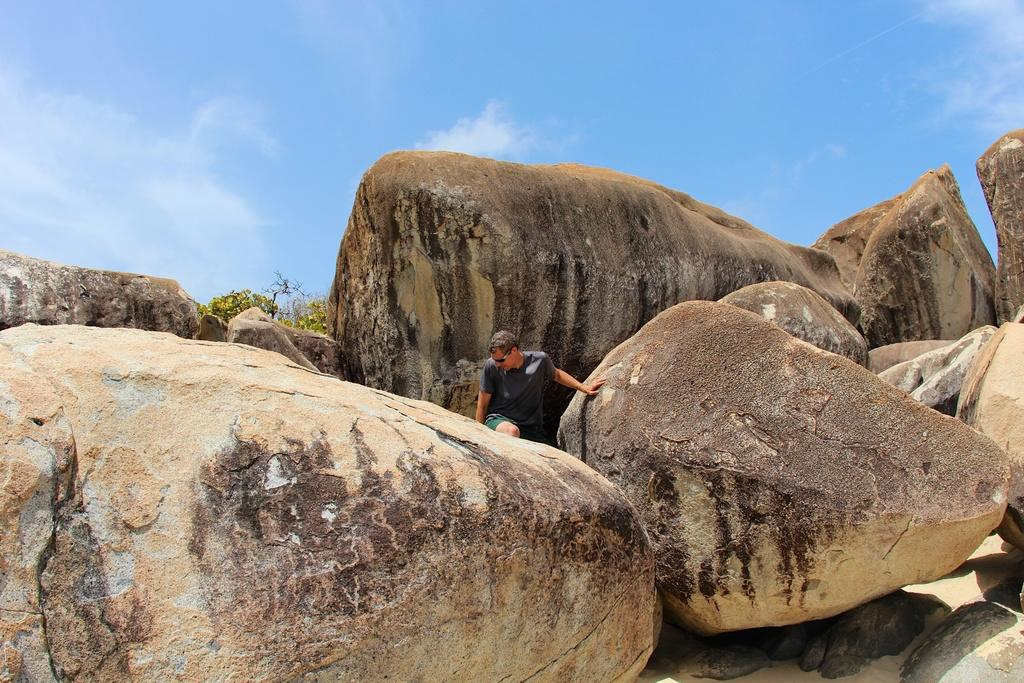Who is the main subject in the image? There is a man in the center of the image. What is surrounding the man? There are rocks around the man. What type of natural environment can be seen in the image? There are trees visible in the image. How would you describe the sky in the image? The sky is visible in the image and appears cloudy. Is the man having trouble sleeping in the image? There is no indication in the image that the man is sleeping or having trouble sleeping. 